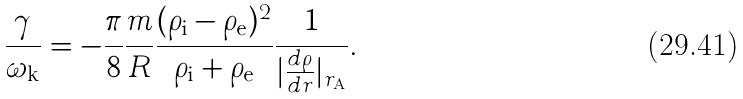Convert formula to latex. <formula><loc_0><loc_0><loc_500><loc_500>\frac { \gamma } { \omega _ { \mathrm k } } = - \frac { \pi } { 8 } \frac { m } { R } \frac { ( \rho _ { \mathrm i } - \rho _ { \mathrm e } ) ^ { 2 } } { \rho _ { \mathrm i } + \rho _ { \mathrm e } } \frac { 1 } { | \frac { d \rho } { d r } | _ { r _ { \mathrm A } } } .</formula> 